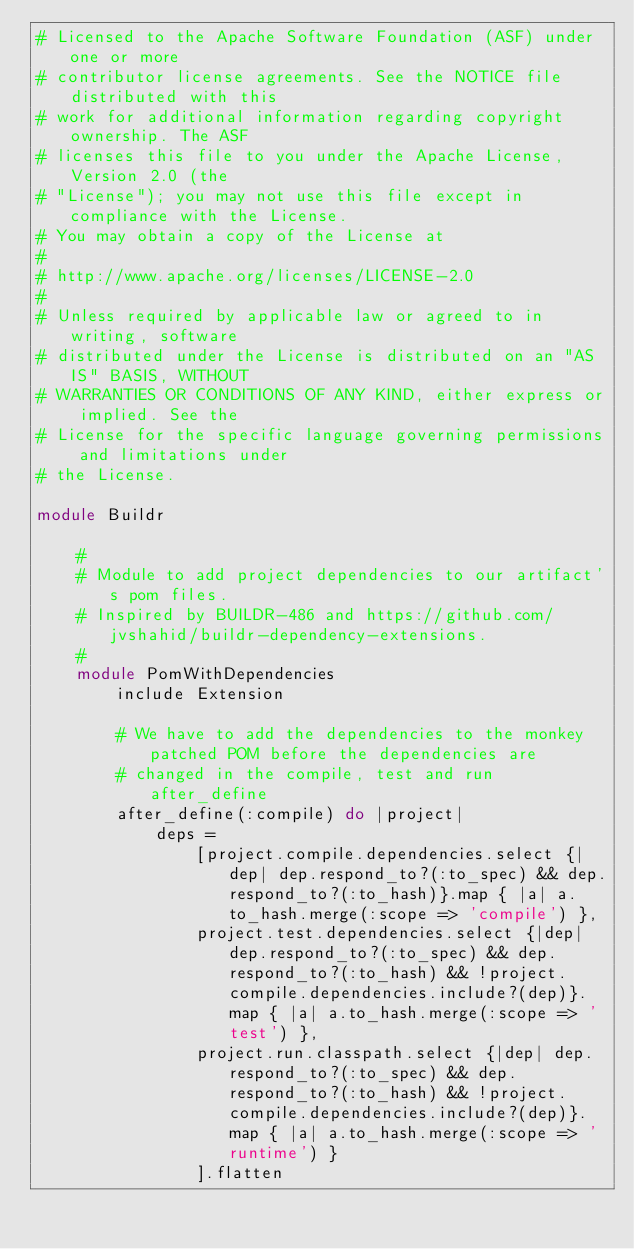Convert code to text. <code><loc_0><loc_0><loc_500><loc_500><_Ruby_># Licensed to the Apache Software Foundation (ASF) under one or more
# contributor license agreements. See the NOTICE file distributed with this
# work for additional information regarding copyright ownership. The ASF
# licenses this file to you under the Apache License, Version 2.0 (the
# "License"); you may not use this file except in compliance with the License.
# You may obtain a copy of the License at
#
# http://www.apache.org/licenses/LICENSE-2.0
#
# Unless required by applicable law or agreed to in writing, software
# distributed under the License is distributed on an "AS IS" BASIS, WITHOUT
# WARRANTIES OR CONDITIONS OF ANY KIND, either express or implied. See the
# License for the specific language governing permissions and limitations under
# the License.

module Buildr

    #
    # Module to add project dependencies to our artifact's pom files. 
    # Inspired by BUILDR-486 and https://github.com/jvshahid/buildr-dependency-extensions.
    #
    module PomWithDependencies
        include Extension

        # We have to add the dependencies to the monkey patched POM before the dependencies are
        # changed in the compile, test and run after_define
        after_define(:compile) do |project|
            deps =
                [project.compile.dependencies.select {|dep| dep.respond_to?(:to_spec) && dep.respond_to?(:to_hash)}.map { |a| a.to_hash.merge(:scope => 'compile') },
                project.test.dependencies.select {|dep| dep.respond_to?(:to_spec) && dep.respond_to?(:to_hash) && !project.compile.dependencies.include?(dep)}.map { |a| a.to_hash.merge(:scope => 'test') },
                project.run.classpath.select {|dep| dep.respond_to?(:to_spec) && dep.respond_to?(:to_hash) && !project.compile.dependencies.include?(dep)}.map { |a| a.to_hash.merge(:scope => 'runtime') }
                ].flatten
</code> 